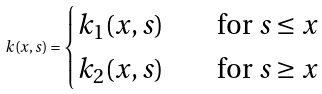Convert formula to latex. <formula><loc_0><loc_0><loc_500><loc_500>k ( x , s ) = \begin{cases} k _ { 1 } ( x , s ) \quad & \text {for $s\leq x$} \\ k _ { 2 } ( x , s ) \quad & \text {for $s \geq x$} \end{cases}</formula> 